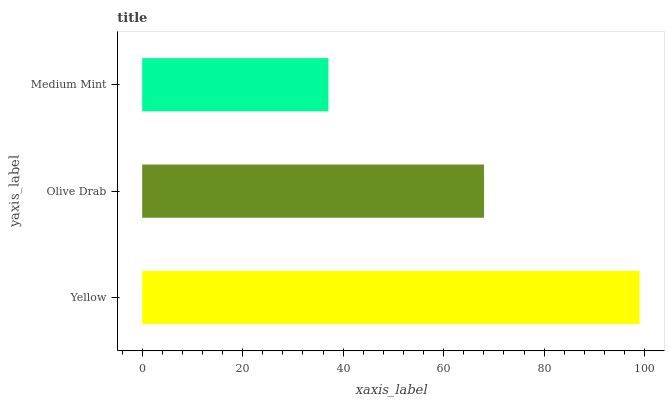Is Medium Mint the minimum?
Answer yes or no. Yes. Is Yellow the maximum?
Answer yes or no. Yes. Is Olive Drab the minimum?
Answer yes or no. No. Is Olive Drab the maximum?
Answer yes or no. No. Is Yellow greater than Olive Drab?
Answer yes or no. Yes. Is Olive Drab less than Yellow?
Answer yes or no. Yes. Is Olive Drab greater than Yellow?
Answer yes or no. No. Is Yellow less than Olive Drab?
Answer yes or no. No. Is Olive Drab the high median?
Answer yes or no. Yes. Is Olive Drab the low median?
Answer yes or no. Yes. Is Medium Mint the high median?
Answer yes or no. No. Is Medium Mint the low median?
Answer yes or no. No. 